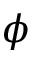Convert formula to latex. <formula><loc_0><loc_0><loc_500><loc_500>\phi</formula> 